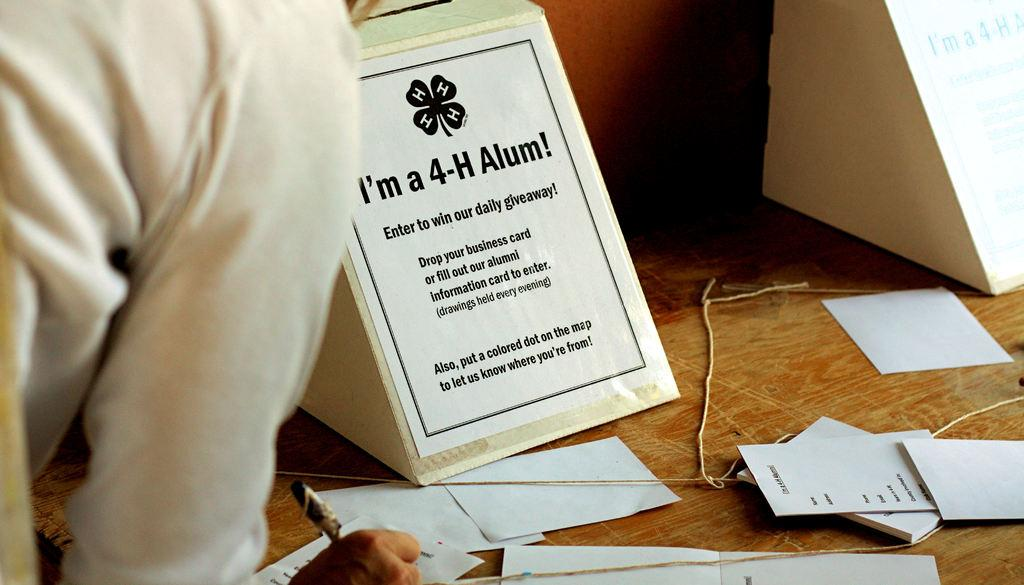What is the main object in the image? There is a lucky draw box in the image. What is placed in front of the box? There are many chits in front of the box. What is the person on the left side of the image doing? The person is writing something on a chit. What type of statement can be seen on the sun in the image? There is no sun present in the image, and therefore no statement can be seen on it. 